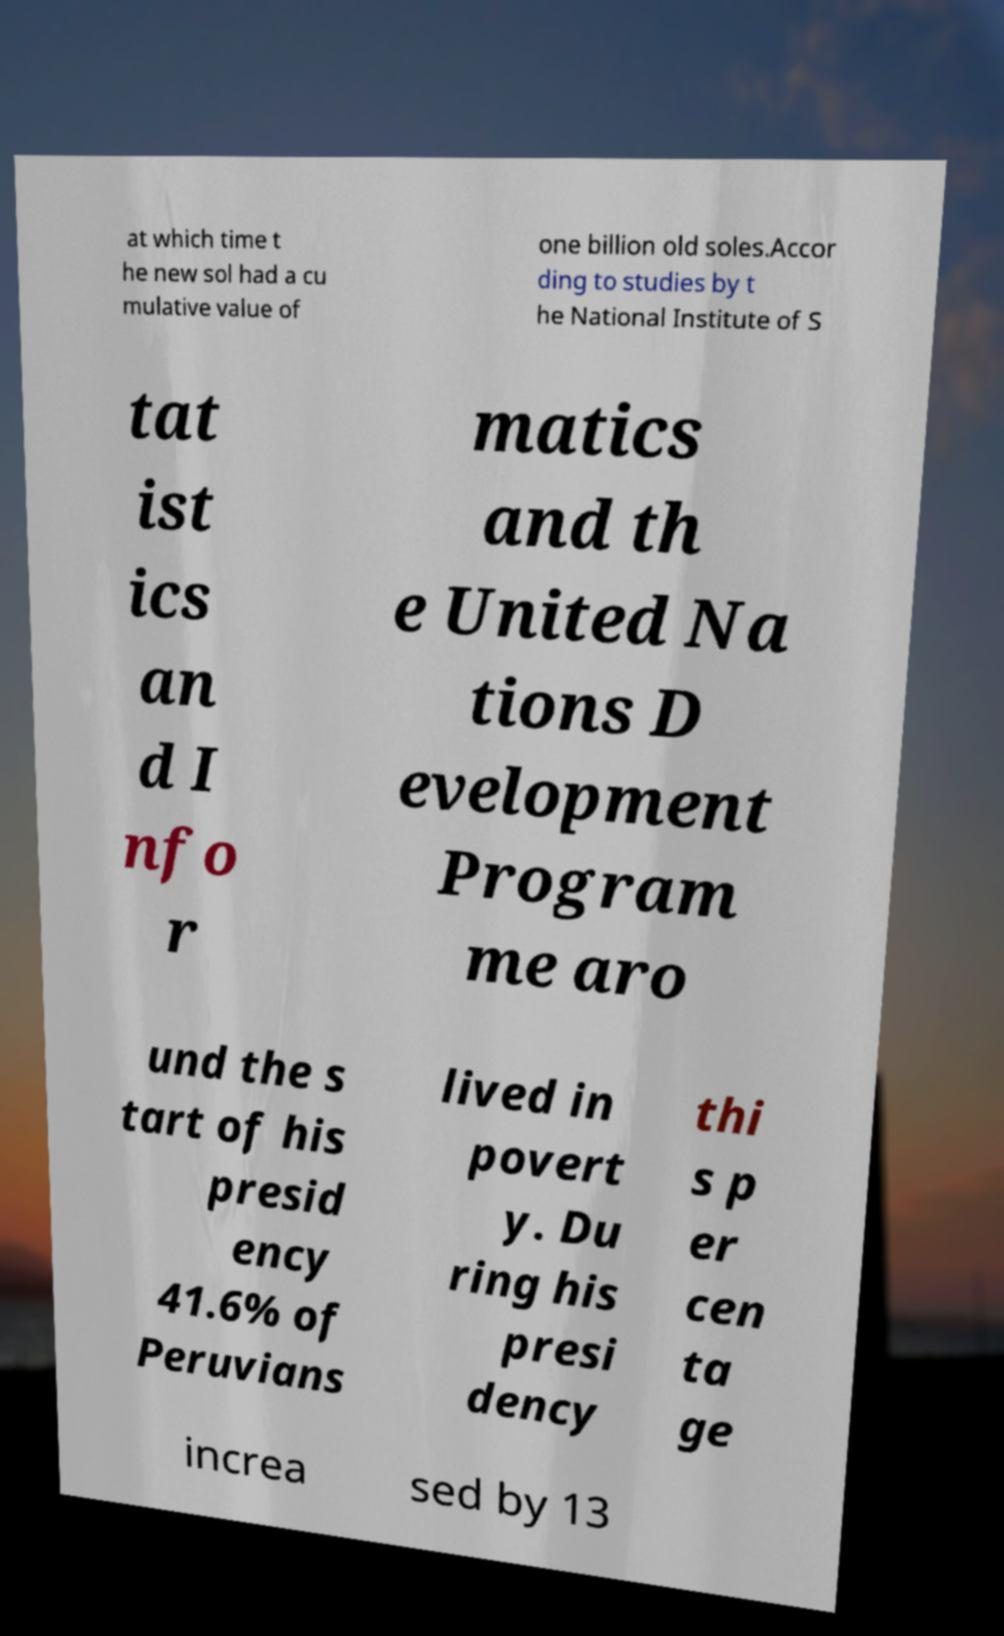Can you read and provide the text displayed in the image?This photo seems to have some interesting text. Can you extract and type it out for me? at which time t he new sol had a cu mulative value of one billion old soles.Accor ding to studies by t he National Institute of S tat ist ics an d I nfo r matics and th e United Na tions D evelopment Program me aro und the s tart of his presid ency 41.6% of Peruvians lived in povert y. Du ring his presi dency thi s p er cen ta ge increa sed by 13 